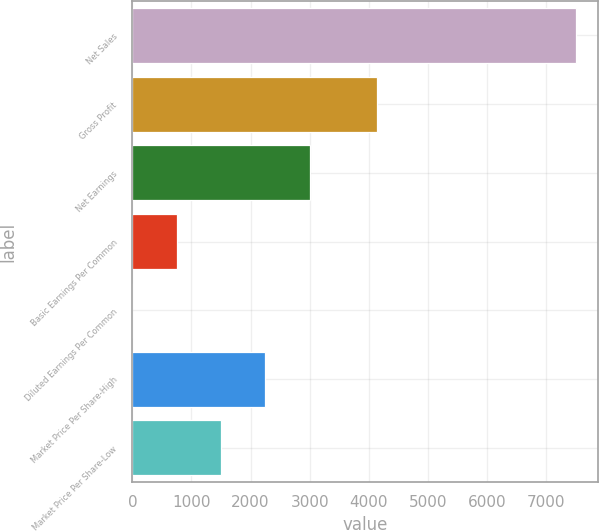<chart> <loc_0><loc_0><loc_500><loc_500><bar_chart><fcel>Net Sales<fcel>Gross Profit<fcel>Net Earnings<fcel>Basic Earnings Per Common<fcel>Diluted Earnings Per Common<fcel>Market Price Per Share-High<fcel>Market Price Per Share-Low<nl><fcel>7497.7<fcel>4144.8<fcel>2999.49<fcel>750.39<fcel>0.69<fcel>2249.79<fcel>1500.09<nl></chart> 